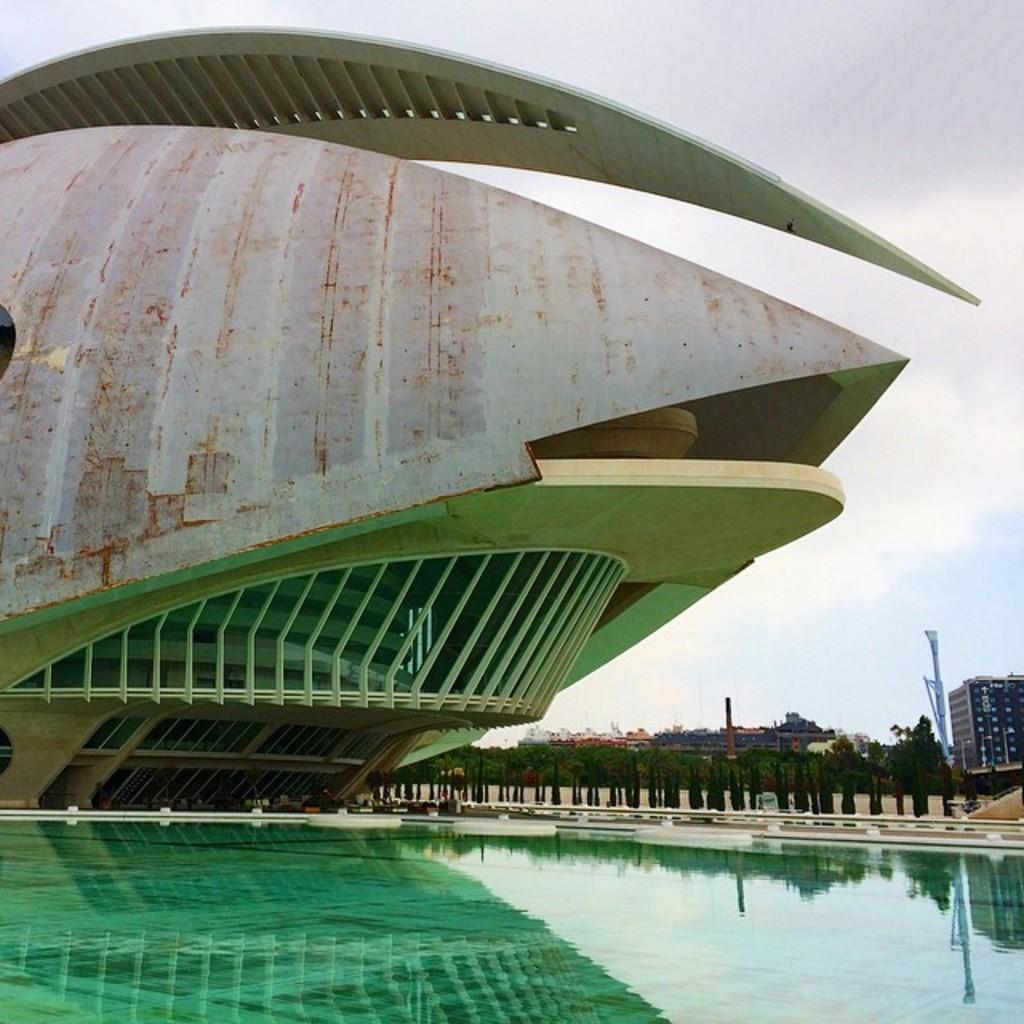Describe this image in one or two sentences. In the center of the image we can see building. At the bottom of the image we can see water. In the background we can see buildings, trees, poles, sky and clouds. 